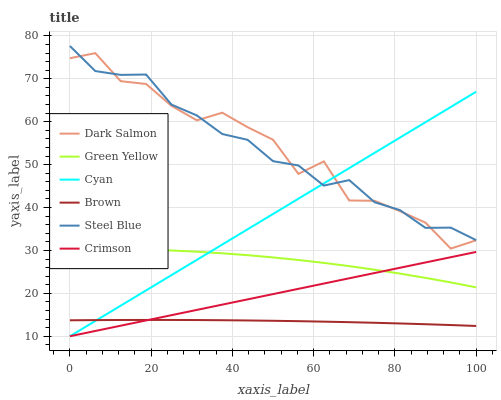Does Brown have the minimum area under the curve?
Answer yes or no. Yes. Does Dark Salmon have the maximum area under the curve?
Answer yes or no. Yes. Does Steel Blue have the minimum area under the curve?
Answer yes or no. No. Does Steel Blue have the maximum area under the curve?
Answer yes or no. No. Is Cyan the smoothest?
Answer yes or no. Yes. Is Dark Salmon the roughest?
Answer yes or no. Yes. Is Steel Blue the smoothest?
Answer yes or no. No. Is Steel Blue the roughest?
Answer yes or no. No. Does Crimson have the lowest value?
Answer yes or no. Yes. Does Dark Salmon have the lowest value?
Answer yes or no. No. Does Steel Blue have the highest value?
Answer yes or no. Yes. Does Dark Salmon have the highest value?
Answer yes or no. No. Is Brown less than Green Yellow?
Answer yes or no. Yes. Is Dark Salmon greater than Brown?
Answer yes or no. Yes. Does Cyan intersect Steel Blue?
Answer yes or no. Yes. Is Cyan less than Steel Blue?
Answer yes or no. No. Is Cyan greater than Steel Blue?
Answer yes or no. No. Does Brown intersect Green Yellow?
Answer yes or no. No. 